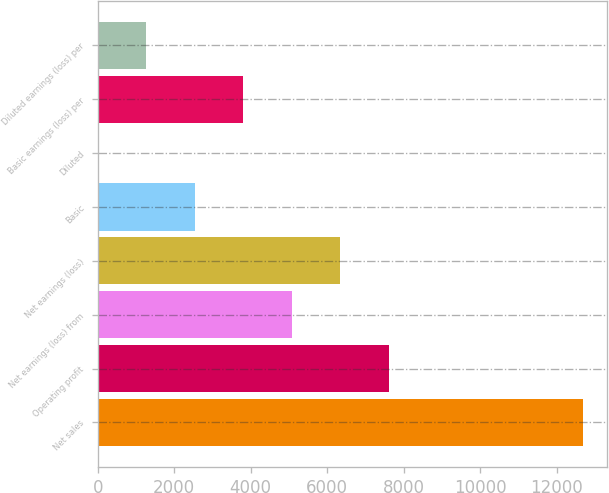<chart> <loc_0><loc_0><loc_500><loc_500><bar_chart><fcel>Net sales<fcel>Operating profit<fcel>Net earnings (loss) from<fcel>Net earnings (loss)<fcel>Basic<fcel>Diluted<fcel>Basic earnings (loss) per<fcel>Diluted earnings (loss) per<nl><fcel>12685<fcel>7612.31<fcel>5075.95<fcel>6344.13<fcel>2539.59<fcel>3.23<fcel>3807.77<fcel>1271.41<nl></chart> 